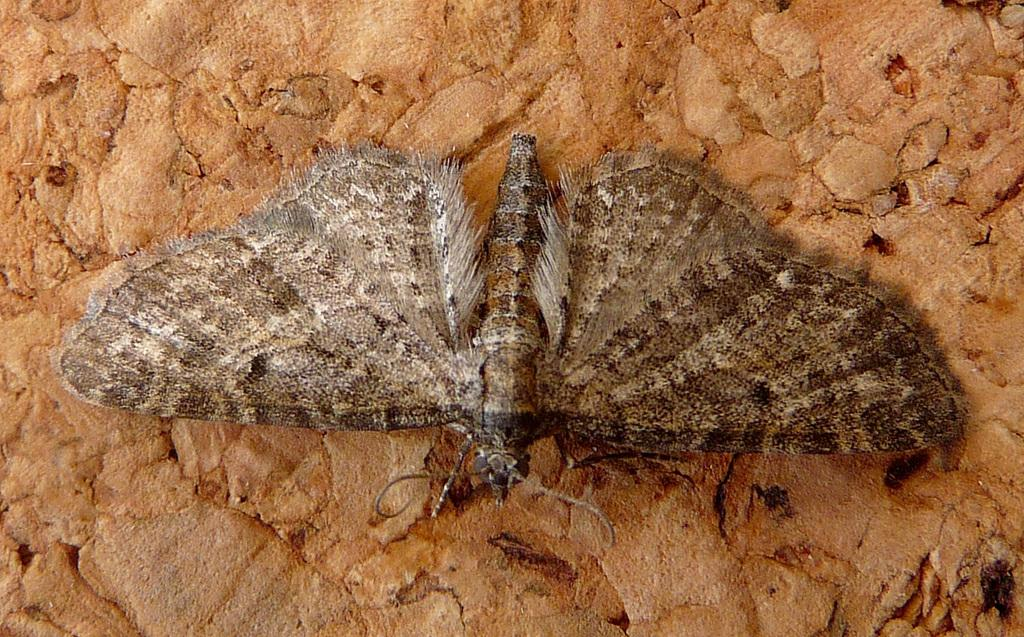Where was the image taken? The image was taken outdoors. What can be seen in the background of the image? There is a rock in the background of the image. What is on the rock in the image? There is a butterfly on the rock in the image. How many boats can be seen in the image? There are no boats present in the image. What type of stem is visible in the image? There is no stem present in the image. 